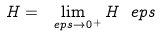<formula> <loc_0><loc_0><loc_500><loc_500>H = \lim _ { \ e p s \rightarrow 0 ^ { + } } H _ { \ } e p s</formula> 